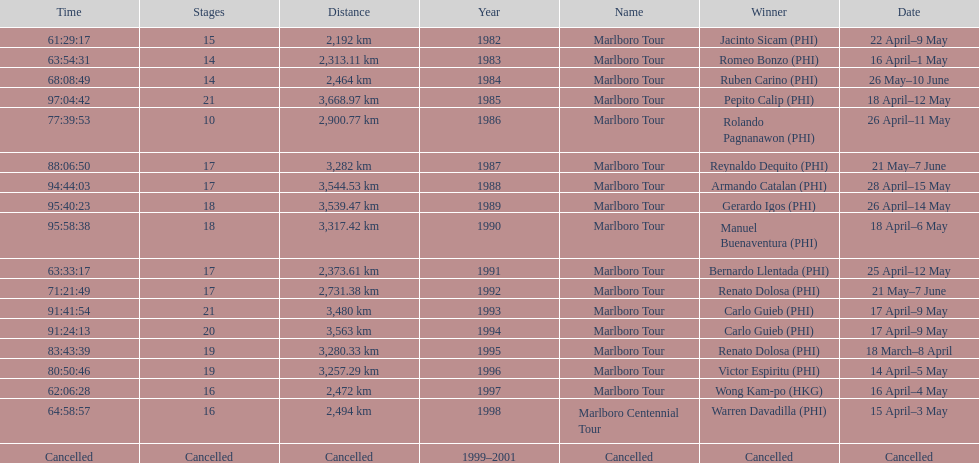What was the largest distance traveled for the marlboro tour? 3,668.97 km. 